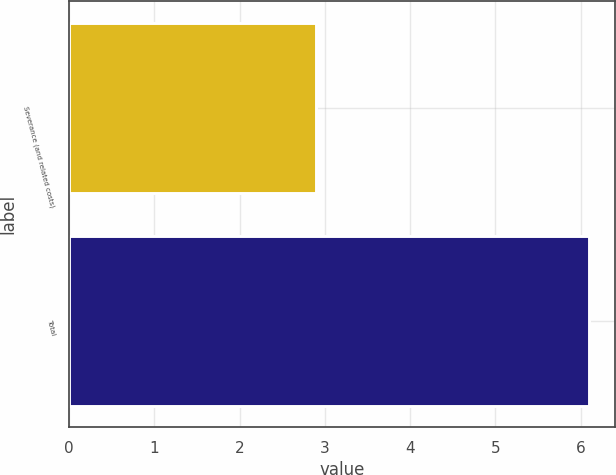Convert chart to OTSL. <chart><loc_0><loc_0><loc_500><loc_500><bar_chart><fcel>Severance (and related costs)<fcel>Total<nl><fcel>2.9<fcel>6.1<nl></chart> 